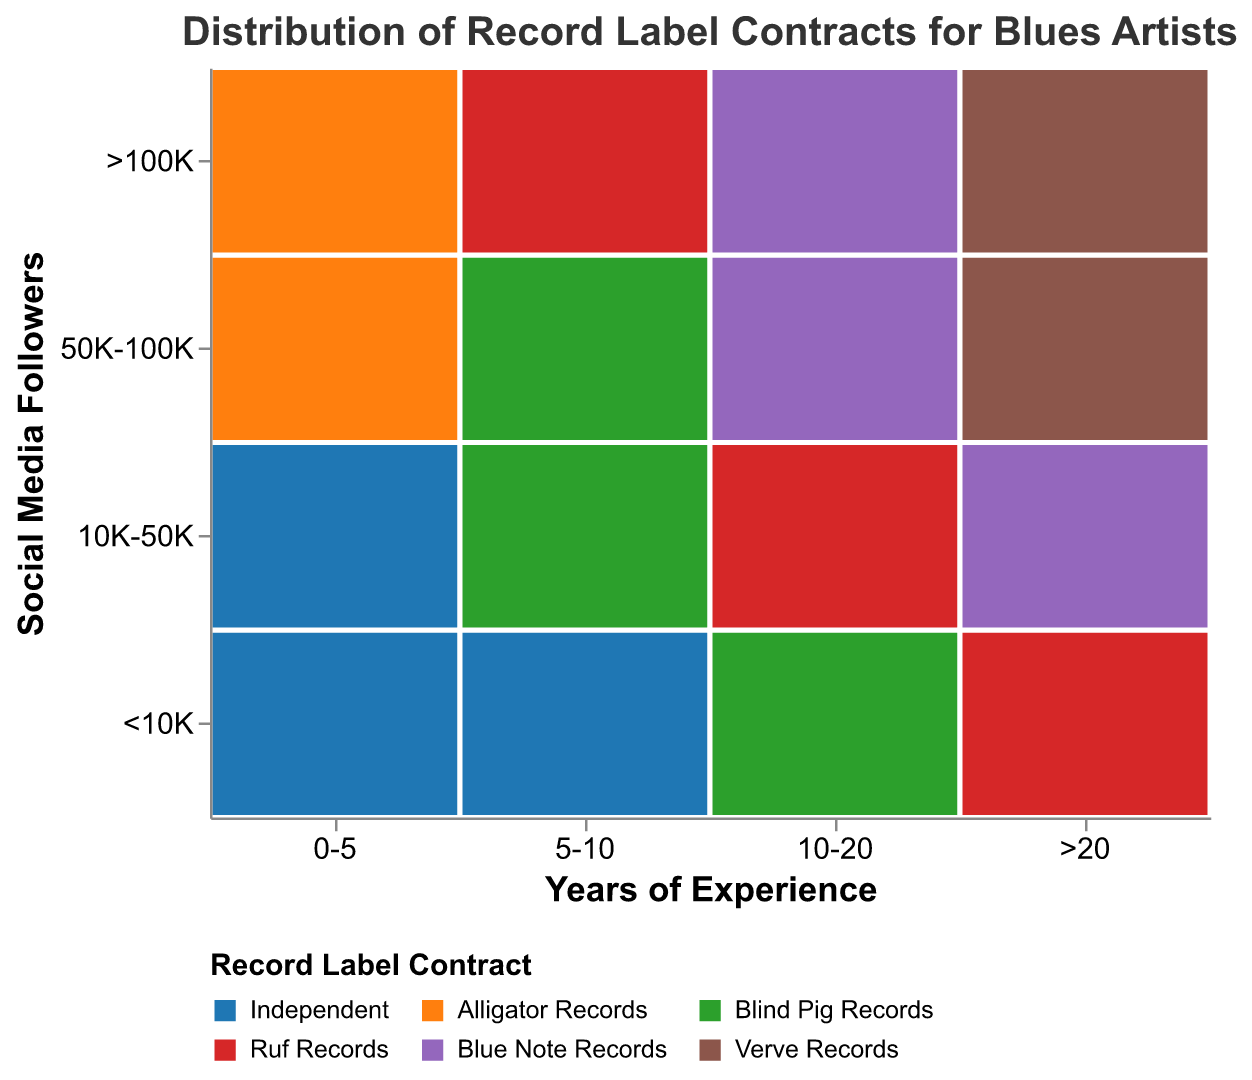What's the title of the figure? Look at the top of the figure where the title is usually located. The title provides an overview of the plot's content.
Answer: Distribution of Record Label Contracts for Blues Artists What does the x-axis represent? Examine the labels and title along the horizontal axis to understand what variable it indicates.
Answer: Years of Experience Which record label is associated with the least experienced blues artists who have the highest social media following? Check the segment corresponding to "0-5 years" of experience on the x-axis and ">100K" followers on the y-axis and identify the record label's color.
Answer: Alligator Records How many different record labels are present in the plot? Count the distinct colors in the plot that are associated with different record labels.
Answer: 6 Which record label is associated with artists having 5-10 years of experience and 50K-100K followers? Look at the intersection between the "5-10 years" on the x-axis and "50K-100K" on the y-axis, then observe the corresponding color to identify the record label.
Answer: Blind Pig Records Do artists with more than 20 years of experience and 10K-50K followers sign with the same record label as those with 10-20 years of experience and 10K-50K followers? Compare the corresponding segments in the chart for both experience levels and check if they share the same color, indicating the same record label.
Answer: No For artists with more than 20 years of experience, which record label appears the most frequently across different follower brackets? Observe the segments for ">20" years of experience and see which color appears most often across different social media followings.
Answer: Ruf Records Which social media following bracket has the most variety of record labels for artists with 10-20 years of experience? Look at the segments corresponding to "10-20 years" of experience for each social media follower bracket and count the number of different colors.
Answer: >100K Are there any record labels that only appear for artists with a specific range of years of experience? If so, identify them. Look for colors that are only present in one particular x-axis segment (Years of Experience), ensuring they do not appear in others.
Answer: Verve Records (only for >20 years experience) Which record labels are associated with artists having the least social media followers (<10K) across all experience levels? Check the segments for "<10K" followers across all x-axis segments and list the colors (record labels) that appear.
Answer: Independent, Blind Pig Records, Ruf Records 